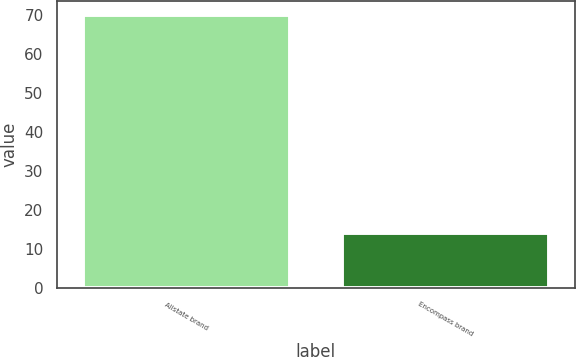<chart> <loc_0><loc_0><loc_500><loc_500><bar_chart><fcel>Allstate brand<fcel>Encompass brand<nl><fcel>70<fcel>14<nl></chart> 